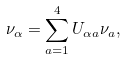Convert formula to latex. <formula><loc_0><loc_0><loc_500><loc_500>\nu _ { \alpha } = \sum _ { a = 1 } ^ { 4 } U _ { \alpha a } \nu _ { a } ,</formula> 